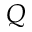<formula> <loc_0><loc_0><loc_500><loc_500>Q</formula> 